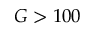<formula> <loc_0><loc_0><loc_500><loc_500>G > 1 0 0</formula> 